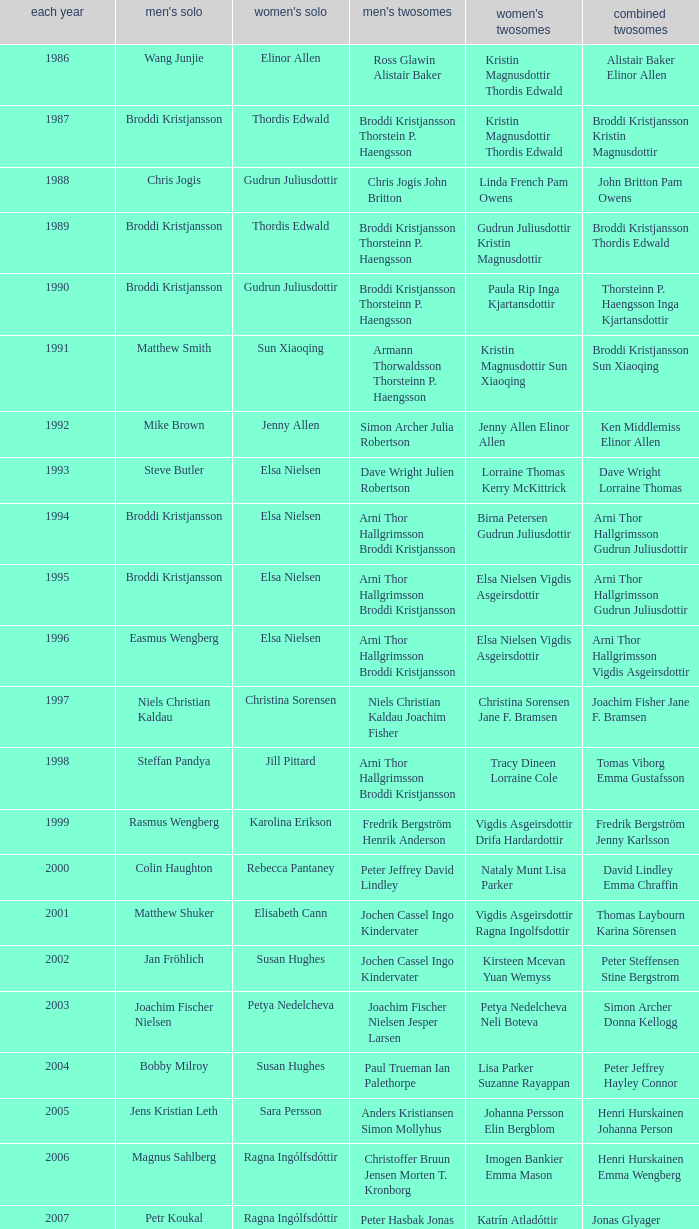Which mixed doubles happened later than 2011? Chou Tien-chen Chiang Mei-hui. 